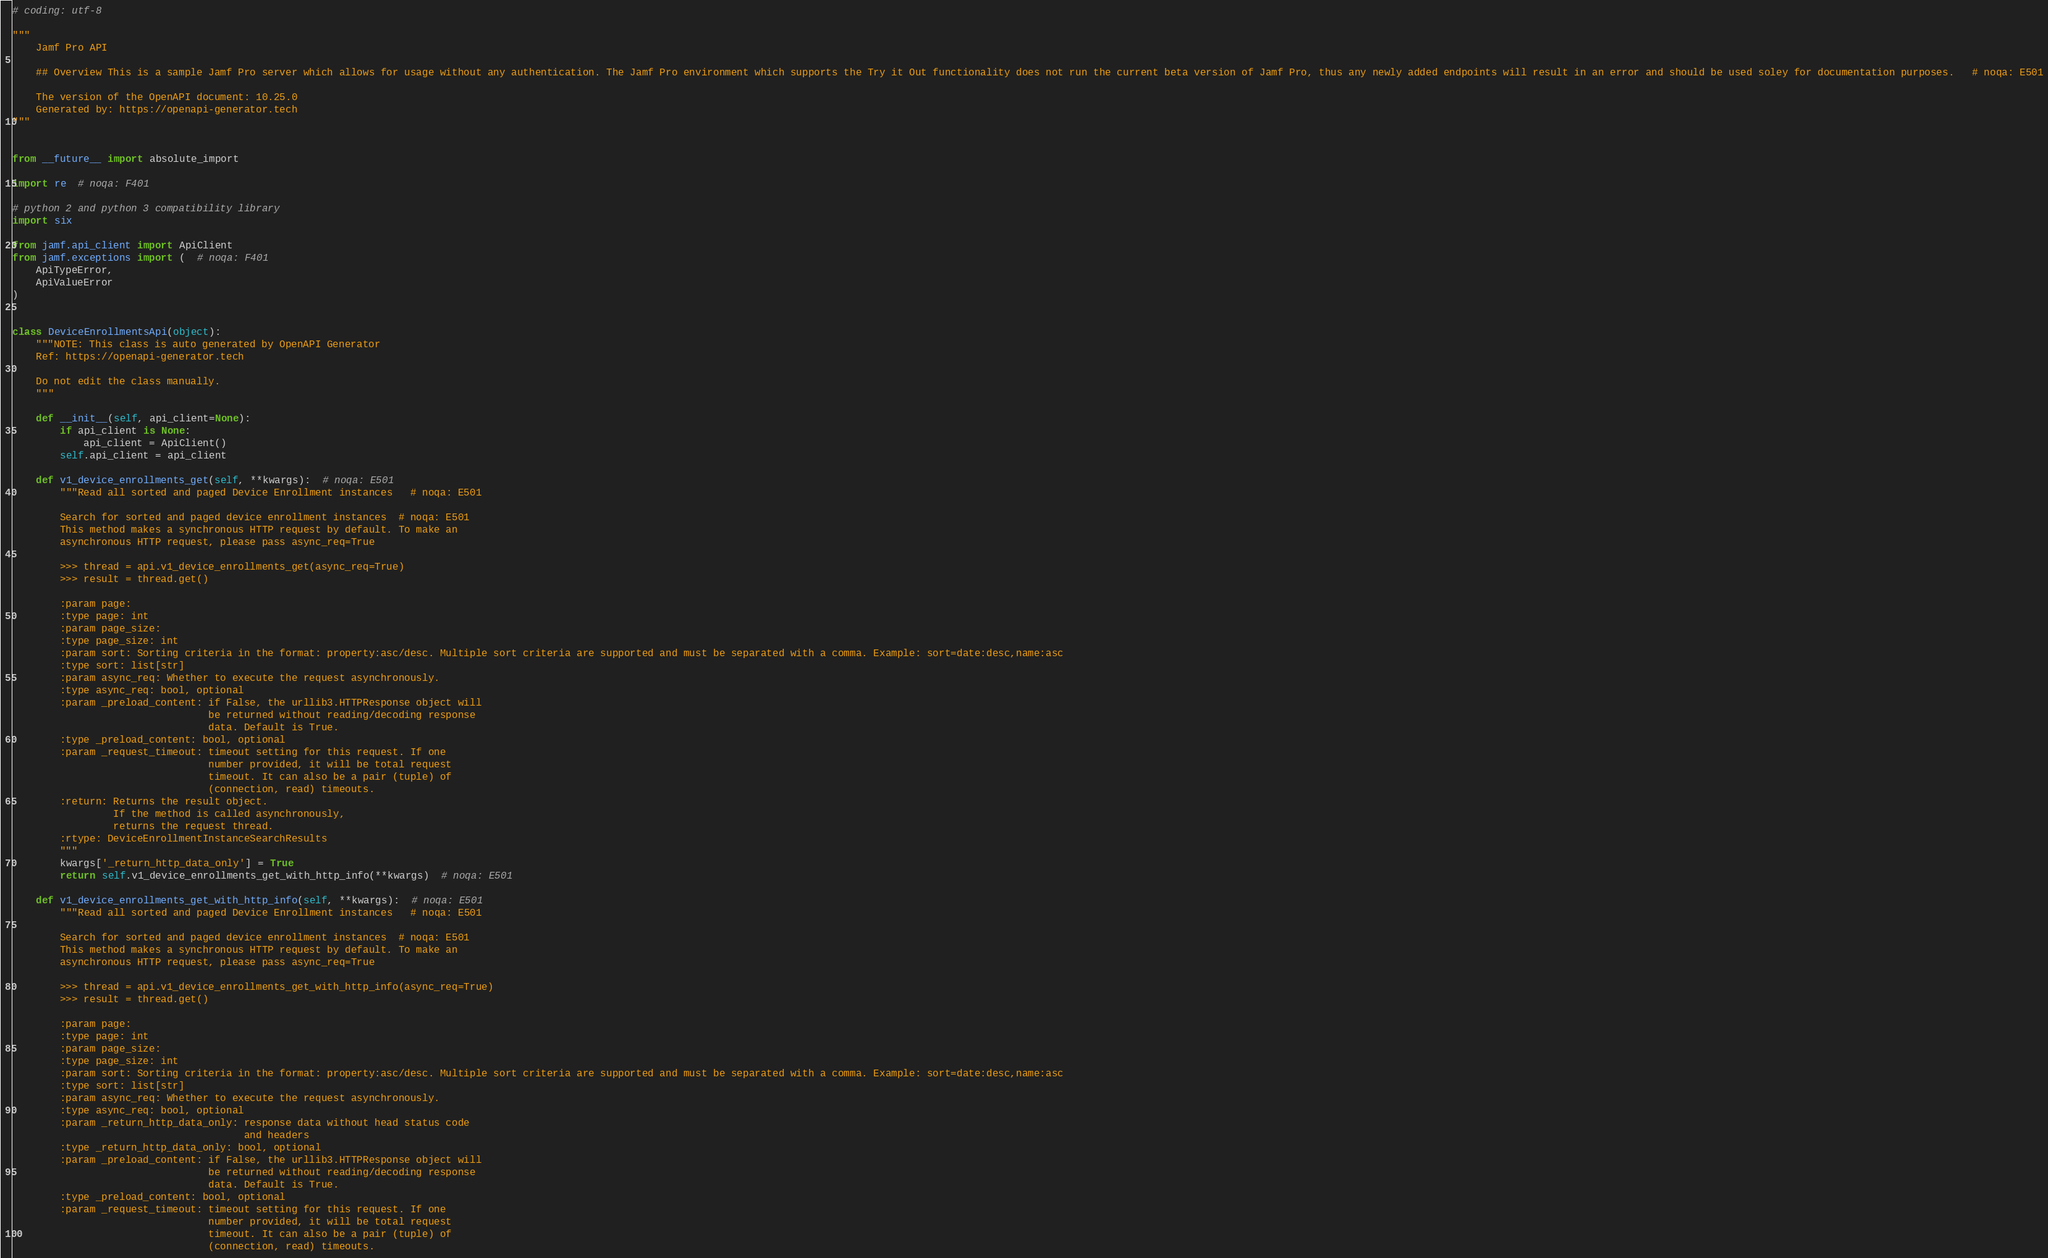<code> <loc_0><loc_0><loc_500><loc_500><_Python_># coding: utf-8

"""
    Jamf Pro API

    ## Overview This is a sample Jamf Pro server which allows for usage without any authentication. The Jamf Pro environment which supports the Try it Out functionality does not run the current beta version of Jamf Pro, thus any newly added endpoints will result in an error and should be used soley for documentation purposes.   # noqa: E501

    The version of the OpenAPI document: 10.25.0
    Generated by: https://openapi-generator.tech
"""


from __future__ import absolute_import

import re  # noqa: F401

# python 2 and python 3 compatibility library
import six

from jamf.api_client import ApiClient
from jamf.exceptions import (  # noqa: F401
    ApiTypeError,
    ApiValueError
)


class DeviceEnrollmentsApi(object):
    """NOTE: This class is auto generated by OpenAPI Generator
    Ref: https://openapi-generator.tech

    Do not edit the class manually.
    """

    def __init__(self, api_client=None):
        if api_client is None:
            api_client = ApiClient()
        self.api_client = api_client

    def v1_device_enrollments_get(self, **kwargs):  # noqa: E501
        """Read all sorted and paged Device Enrollment instances   # noqa: E501

        Search for sorted and paged device enrollment instances  # noqa: E501
        This method makes a synchronous HTTP request by default. To make an
        asynchronous HTTP request, please pass async_req=True

        >>> thread = api.v1_device_enrollments_get(async_req=True)
        >>> result = thread.get()

        :param page:
        :type page: int
        :param page_size:
        :type page_size: int
        :param sort: Sorting criteria in the format: property:asc/desc. Multiple sort criteria are supported and must be separated with a comma. Example: sort=date:desc,name:asc 
        :type sort: list[str]
        :param async_req: Whether to execute the request asynchronously.
        :type async_req: bool, optional
        :param _preload_content: if False, the urllib3.HTTPResponse object will
                                 be returned without reading/decoding response
                                 data. Default is True.
        :type _preload_content: bool, optional
        :param _request_timeout: timeout setting for this request. If one
                                 number provided, it will be total request
                                 timeout. It can also be a pair (tuple) of
                                 (connection, read) timeouts.
        :return: Returns the result object.
                 If the method is called asynchronously,
                 returns the request thread.
        :rtype: DeviceEnrollmentInstanceSearchResults
        """
        kwargs['_return_http_data_only'] = True
        return self.v1_device_enrollments_get_with_http_info(**kwargs)  # noqa: E501

    def v1_device_enrollments_get_with_http_info(self, **kwargs):  # noqa: E501
        """Read all sorted and paged Device Enrollment instances   # noqa: E501

        Search for sorted and paged device enrollment instances  # noqa: E501
        This method makes a synchronous HTTP request by default. To make an
        asynchronous HTTP request, please pass async_req=True

        >>> thread = api.v1_device_enrollments_get_with_http_info(async_req=True)
        >>> result = thread.get()

        :param page:
        :type page: int
        :param page_size:
        :type page_size: int
        :param sort: Sorting criteria in the format: property:asc/desc. Multiple sort criteria are supported and must be separated with a comma. Example: sort=date:desc,name:asc 
        :type sort: list[str]
        :param async_req: Whether to execute the request asynchronously.
        :type async_req: bool, optional
        :param _return_http_data_only: response data without head status code
                                       and headers
        :type _return_http_data_only: bool, optional
        :param _preload_content: if False, the urllib3.HTTPResponse object will
                                 be returned without reading/decoding response
                                 data. Default is True.
        :type _preload_content: bool, optional
        :param _request_timeout: timeout setting for this request. If one
                                 number provided, it will be total request
                                 timeout. It can also be a pair (tuple) of
                                 (connection, read) timeouts.</code> 